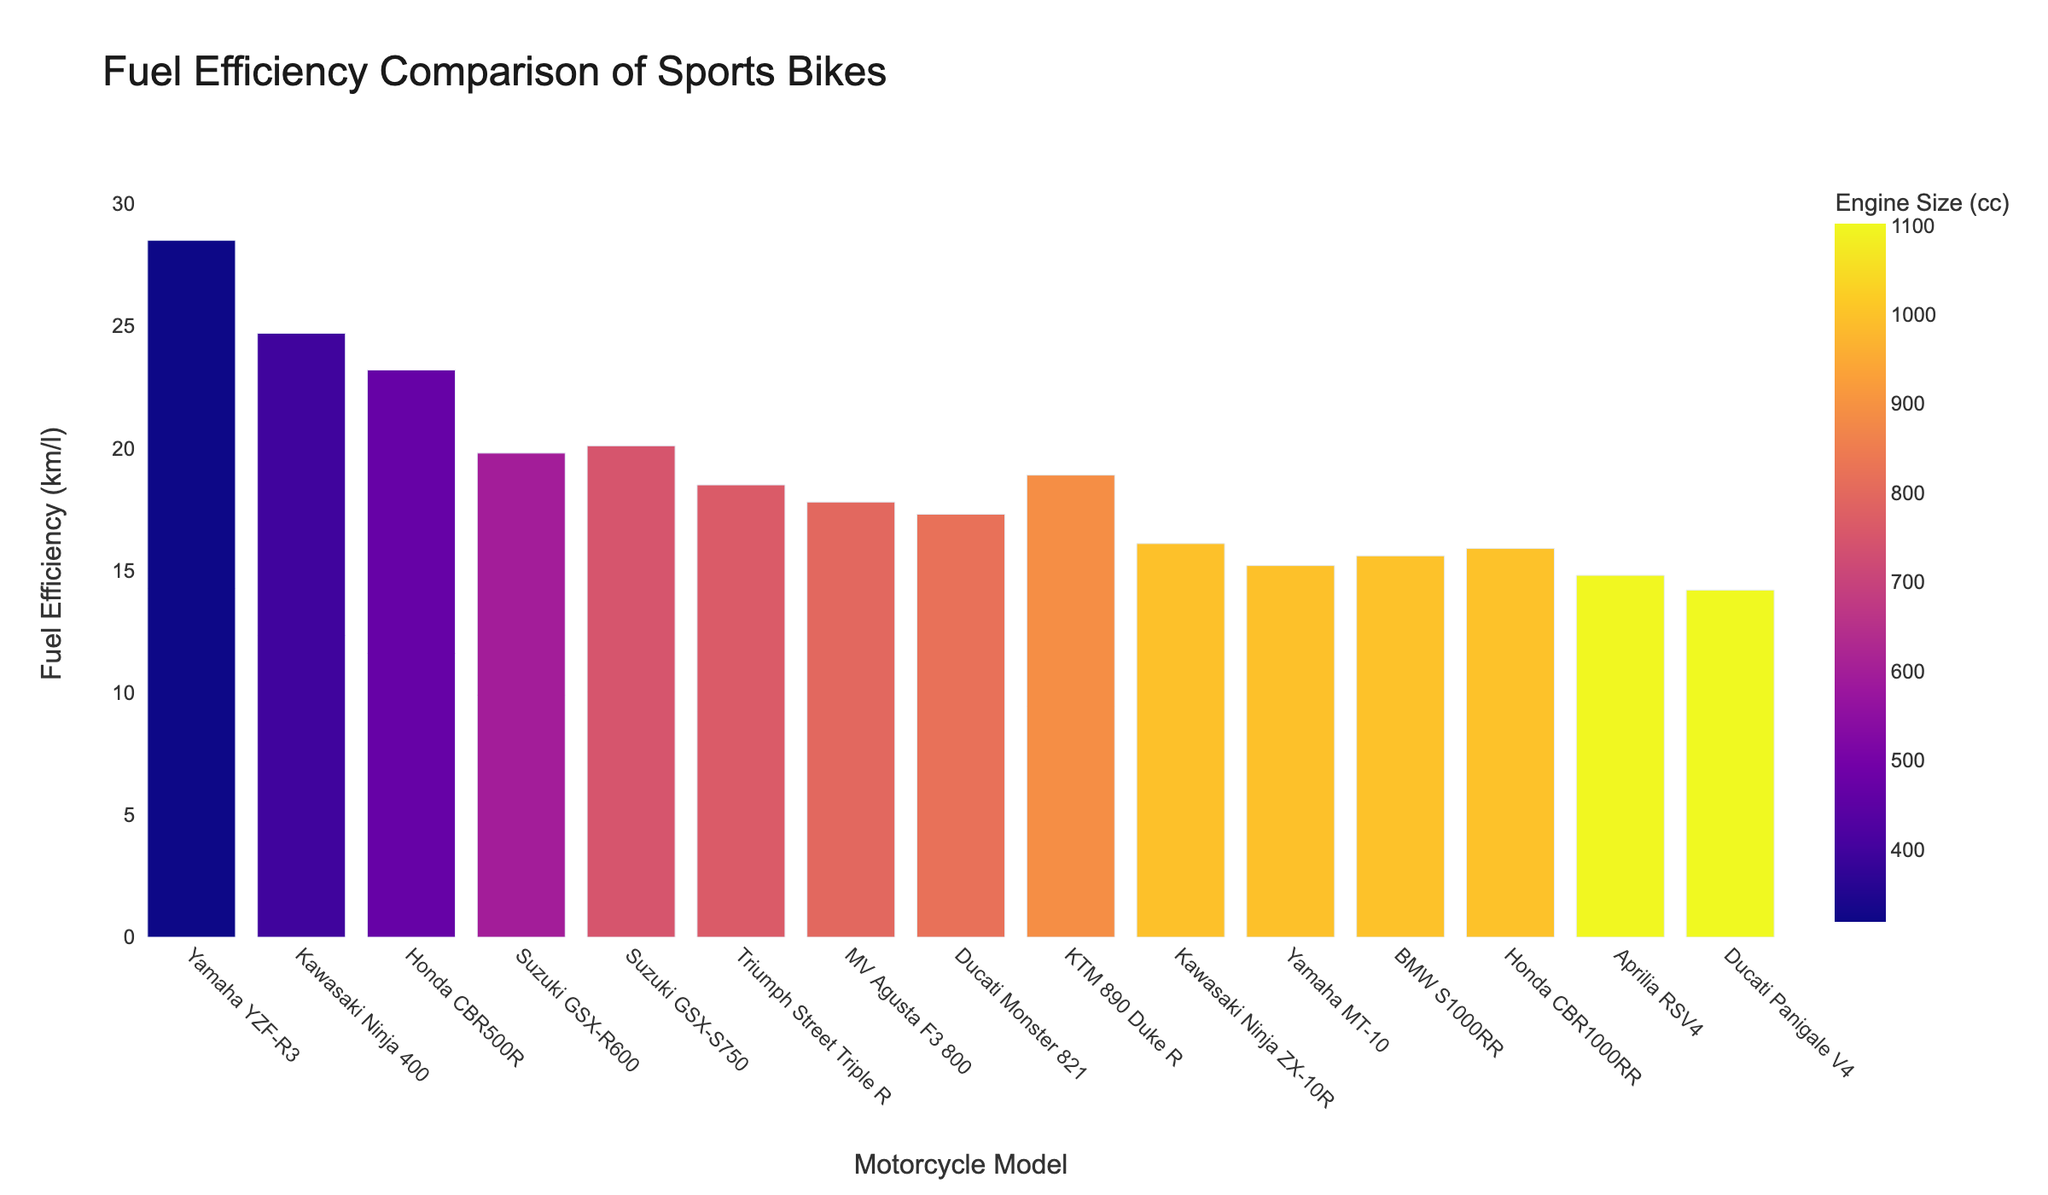What's the most fuel-efficient sports bike in the chart? The most fuel-efficient sports bike will be the one with the highest bar on the figure. Yamaha YZF-R3 has the highest fuel efficiency at 28.5 km/l.
Answer: Yamaha YZF-R3 Which bike has the lowest fuel efficiency, and what is its engine displacement? The bike with the shortest bar will have the lowest fuel efficiency. Ducati Panigale V4 has the lowest fuel efficiency at 14.2 km/l, and its engine displacement is 1103 cc.
Answer: Ducati Panigale V4, 1103 cc How does the fuel efficiency of the Kawasaki Ninja ZX-10R compare to the Yamaha MT-10? Compare the heights of the bars for Kawasaki Ninja ZX-10R and Yamaha MT-10. Kawasaki Ninja ZX-10R's bar is slightly higher than Yamaha MT-10's, indicating better fuel efficiency. Kawasaki Ninja ZX-10R has 16.1 km/l, while Yamaha MT-10 has 15.2 km/l.
Answer: Kawasaki Ninja ZX-10R is more fuel-efficient What's the average fuel efficiency of bikes with engine displacements greater than 800 cc? Look at the bikes with engine displacements over 800 cc: Ducati Monster 821 (17.3 km/l), BMW S1000RR (15.6 km/l), Kawasaki Ninja ZX-10R (16.1 km/l), Aprilia RSV4 (14.8 km/l), Honda CBR1000RR (15.9 km/l), Yamaha MT-10 (15.2 km/l), Ducati Panigale V4 (14.2 km/l). Average = (17.3 + 15.6 + 16.1 + 14.8 + 15.9 + 15.2 + 14.2) / 7 = 15.7285 km/l.
Answer: 15.7 km/l Which bike has the second-highest fuel efficiency in the 700-800 cc engine category? Identify bikes in the 700-800 cc range: Triumph Street Triple R (18.5 km/l), MV Agusta F3 800 (17.8 km/l), KTM 890 Duke R (18.9 km/l), Suzuki GSX-S750 (20.1 km/l). The second-highest fuel efficiency is MV Agusta F3 800 with 17.8 km/l after Suzuki GSX-S750.
Answer: MV Agusta F3 800 Which bike has a higher fuel efficiency, Honda CBR500R or Suzuki GSX-R600? By how much? Compare the heights of Honda CBR500R and Suzuki GSX-R600 bars. Honda CBR500R's value is 23.2 km/l, and Suzuki GSX-R600's value is 19.8 km/l. Difference: 23.2 - 19.8 = 3.4 km/l.
Answer: Honda CBR500R by 3.4 km/l How does the fuel efficiency trend change with increasing engine displacement? Examine the bars' heights as engine displacement increases. Generally, the fuel efficiency tends to decrease as the engine displacement increases, with some minor fluctuations.
Answer: Decreases Calculate the total fuel efficiency of all bikes with an engine displacement between 750 cc and 900 cc. Identify bikes in this range: Triumph Street Triple R (18.5 km/l), MV Agusta F3 800 (17.8 km/l), KTM 890 Duke R (18.9 km/l), Suzuki GSX-S750 (20.1 km/l). Total: 18.5 + 17.8 + 18.9 + 20.1 = 75.3 km/l.
Answer: 75.3 km/l Is there any bike with fuel efficiency between 15 km/l and 16 km/l? If yes, which one(s)? Look for bars having values between 15 km/l and 16 km/l. BMW S1000RR (15.6 km/l), Honda CBR1000RR (15.9 km/l), and Kawasaki Ninja ZX-10R (16.1 km/l falls just outside the range).
Answer: BMW S1000RR, Honda CBR1000RR 